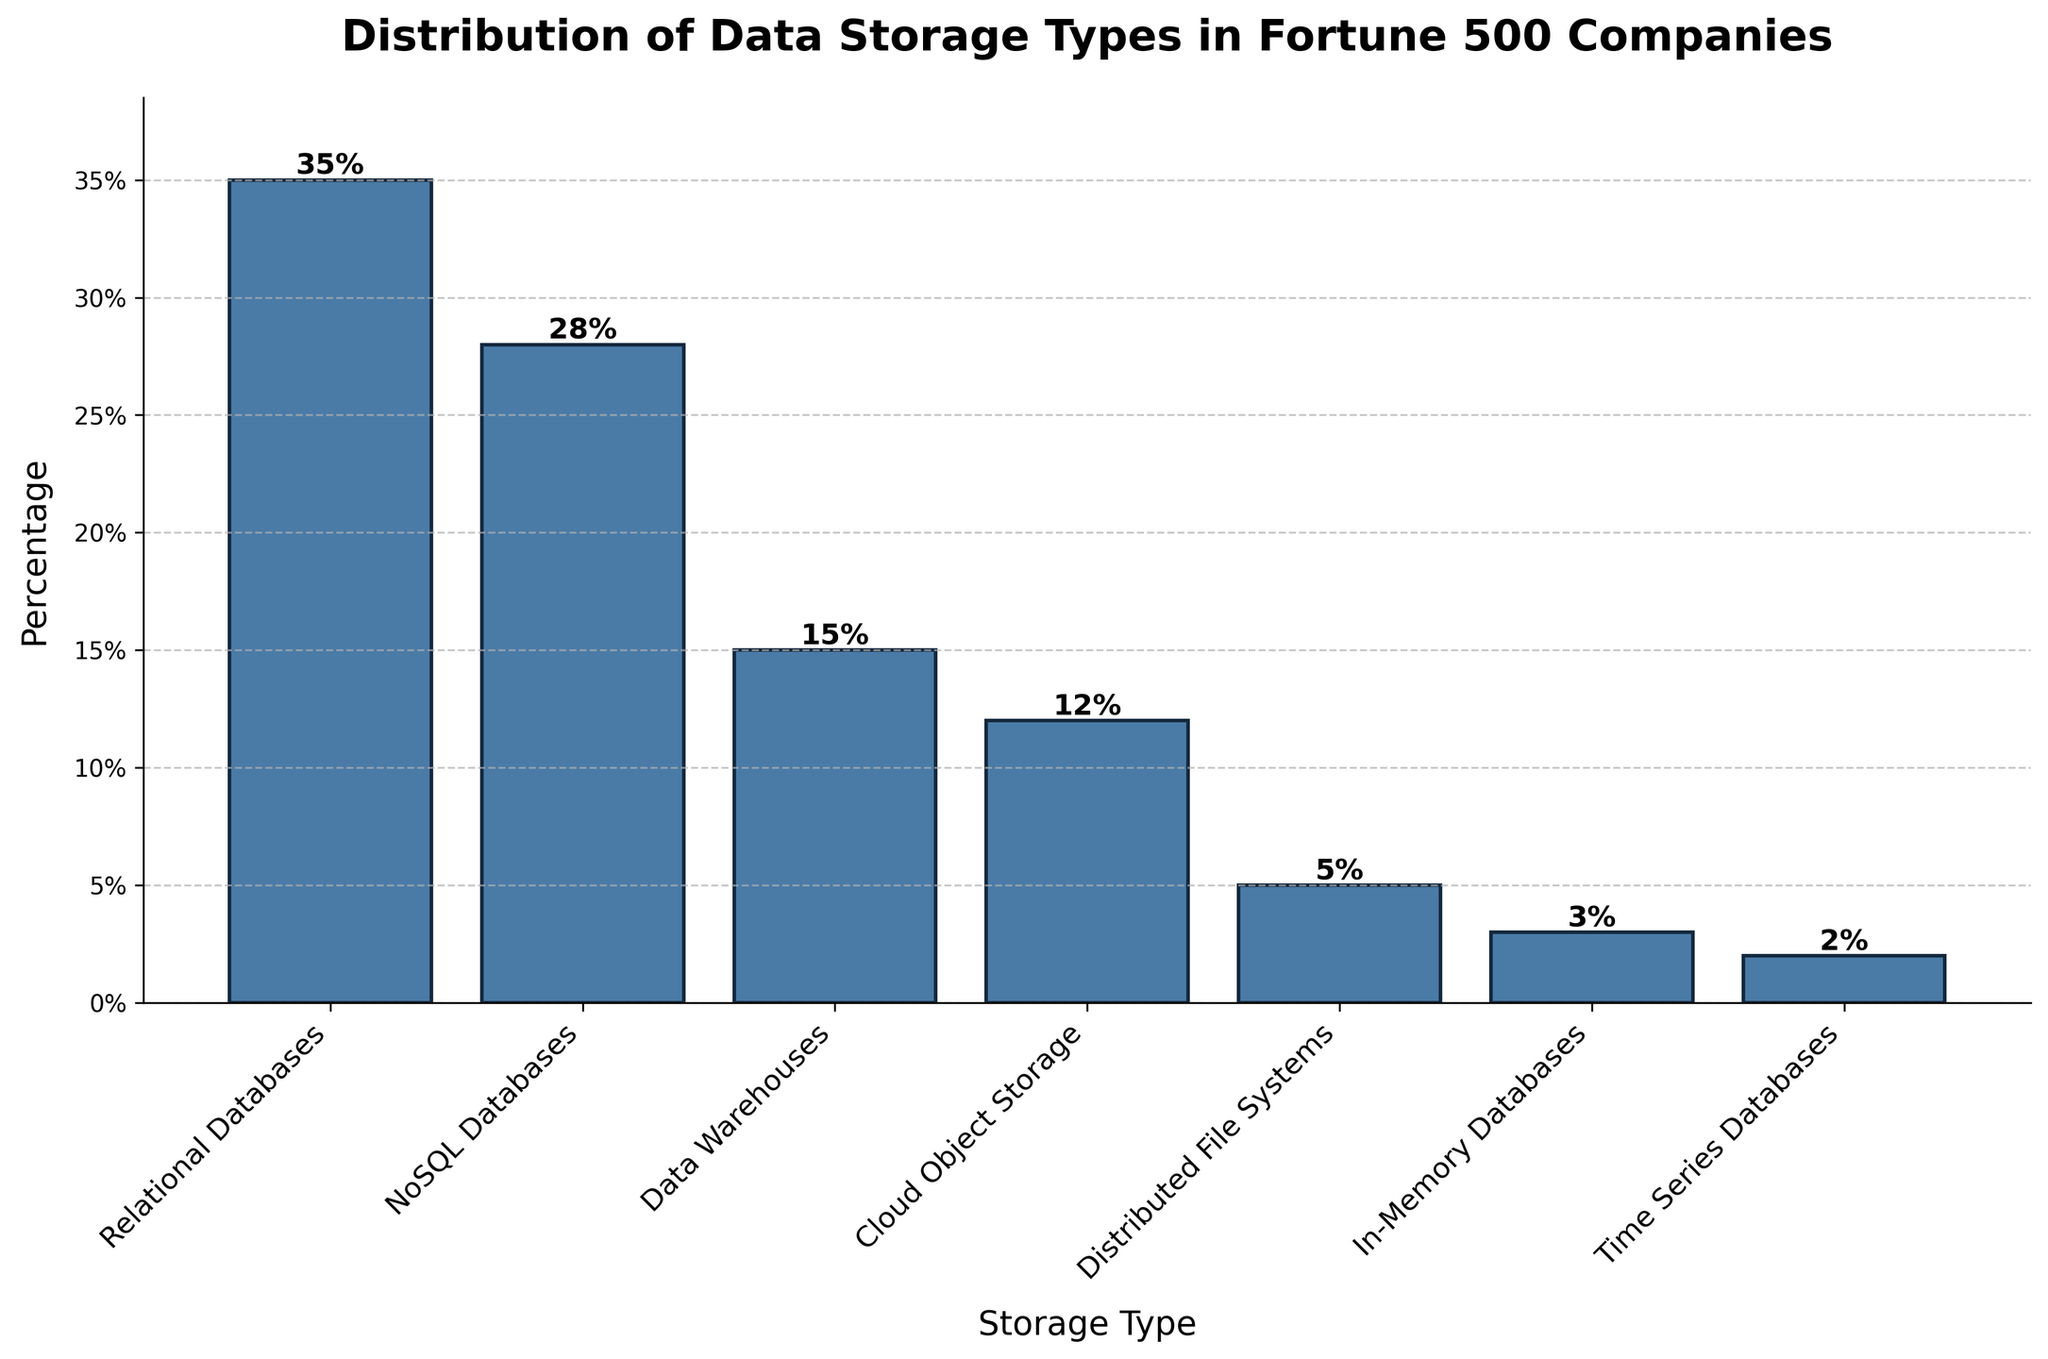Which storage type is the most commonly used among Fortune 500 companies? The highest bar represents the most commonly used storage type among Fortune 500 companies. In this chart, the bar for Relational Databases reaches 35%, which is higher than any other bar.
Answer: Relational Databases Which storage type is used by the least number of Fortune 500 companies? The shortest bar represents the storage type used by the least number of Fortune 500 companies. In this chart, the bar for Time Series Databases reaches 2%, which is the shortest.
Answer: Time Series Databases What is the combined percentage for the top three most commonly used storage types? The top three storage types are Relational Databases (35%), NoSQL Databases (28%), and Data Warehouses (15%). Adding these percentages gives 35% + 28% + 15% = 78%.
Answer: 78% Which storage type has a greater percentage, Cloud Object Storage or Distributed File Systems? By how much? Cloud Object Storage has a percentage of 12% and Distributed File Systems have a percentage of 5%. Subtracting these values gives 12% - 5% = 7%.
Answer: Cloud Object Storage by 7% What is the average percentage use of Cloud Object Storage, In-Memory Databases, and Time Series Databases? Add the percentages for Cloud Object Storage (12%), In-Memory Databases (3%), and Time Series Databases (2%) to get 12% + 3% + 2% = 17%. Divide this sum by 3 to find the average: 17% / 3 ≈ 5.67%.
Answer: 5.67% Between Data Warehouses and NoSQL Databases, which has a higher percentage and by how much? Data Warehouses have a percentage of 15% and NoSQL Databases have a percentage of 28%. Subtracting these values gives 28% - 15% = 13%.
Answer: NoSQL Databases by 13% What percentage of companies use either Relational Databases or In-Memory Databases? Add the percentages for Relational Databases (35%) and In-Memory Databases (3%) to get 35% + 3% = 38%.
Answer: 38% What is the second least commonly used storage type and its percentage? The second shortest bar represents the second least commonly used storage type among Fortune 500 companies. In this chart, In-Memory Databases have a percentage of 3%, which is the second shortest after Time Series Databases (2%).
Answer: In-Memory Databases, 3% How much more are NoSQL Databases used compared to Distributed File Systems? NoSQL Databases have a percentage of 28% and Distributed File Systems have a percentage of 5%. Subtracting these values gives 28% - 5% = 23%.
Answer: 23% Are there more companies using Data Warehouses or Cloud Object Storage, and by what percentage difference? Data Warehouses have a percentage of 15% and Cloud Object Storage has a percentage of 12%. Subtracting these values gives 15% - 12% = 3%.
Answer: Data Warehouses by 3% 